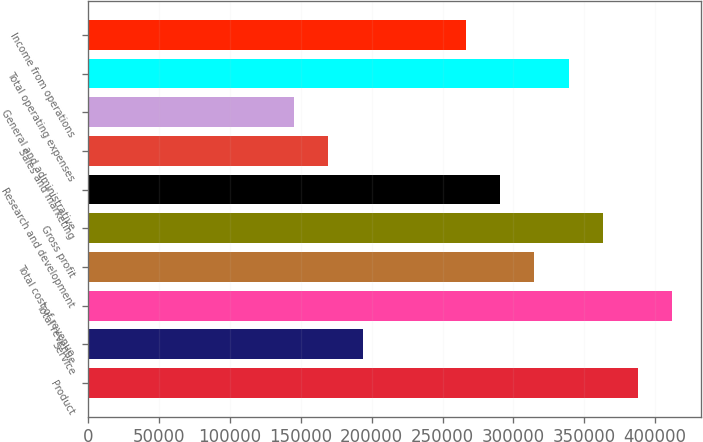Convert chart to OTSL. <chart><loc_0><loc_0><loc_500><loc_500><bar_chart><fcel>Product<fcel>Service<fcel>Total revenue<fcel>Total cost of revenue<fcel>Gross profit<fcel>Research and development<fcel>Sales and marketing<fcel>General and administrative<fcel>Total operating expenses<fcel>Income from operations<nl><fcel>387513<fcel>193757<fcel>411733<fcel>314855<fcel>363294<fcel>290635<fcel>169537<fcel>145318<fcel>339074<fcel>266416<nl></chart> 